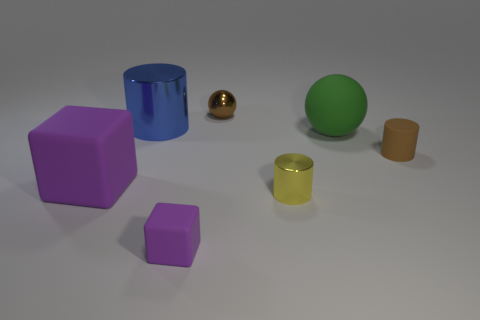How many other rubber cubes are the same color as the large cube?
Give a very brief answer. 1. There is a purple thing on the left side of the big object behind the big matte sphere; how big is it?
Make the answer very short. Large. Are any cylinders visible?
Your answer should be compact. Yes. What number of shiny cylinders are in front of the tiny matte object that is behind the small purple cube?
Make the answer very short. 1. There is a big object that is in front of the large green ball; what is its shape?
Provide a succinct answer. Cube. What is the small sphere behind the cube that is to the left of the cube in front of the yellow metallic thing made of?
Provide a succinct answer. Metal. What number of other things are the same size as the brown rubber object?
Offer a very short reply. 3. What material is the small yellow thing that is the same shape as the big blue metallic object?
Keep it short and to the point. Metal. The matte ball has what color?
Provide a succinct answer. Green. What color is the sphere that is on the right side of the small object that is behind the big green matte sphere?
Keep it short and to the point. Green. 